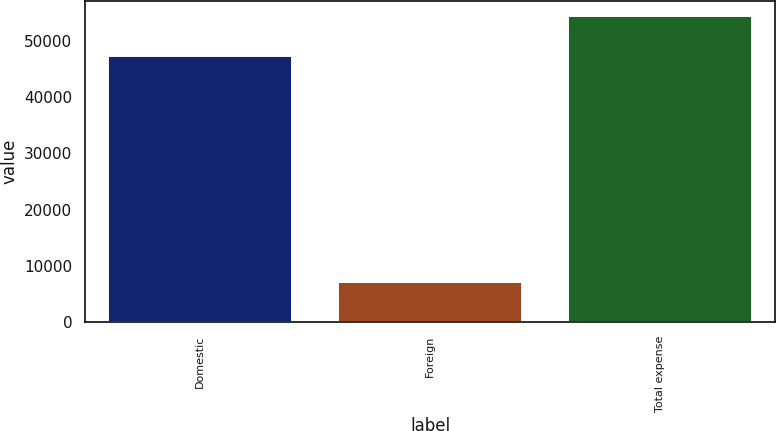<chart> <loc_0><loc_0><loc_500><loc_500><bar_chart><fcel>Domestic<fcel>Foreign<fcel>Total expense<nl><fcel>47370<fcel>7053<fcel>54423<nl></chart> 